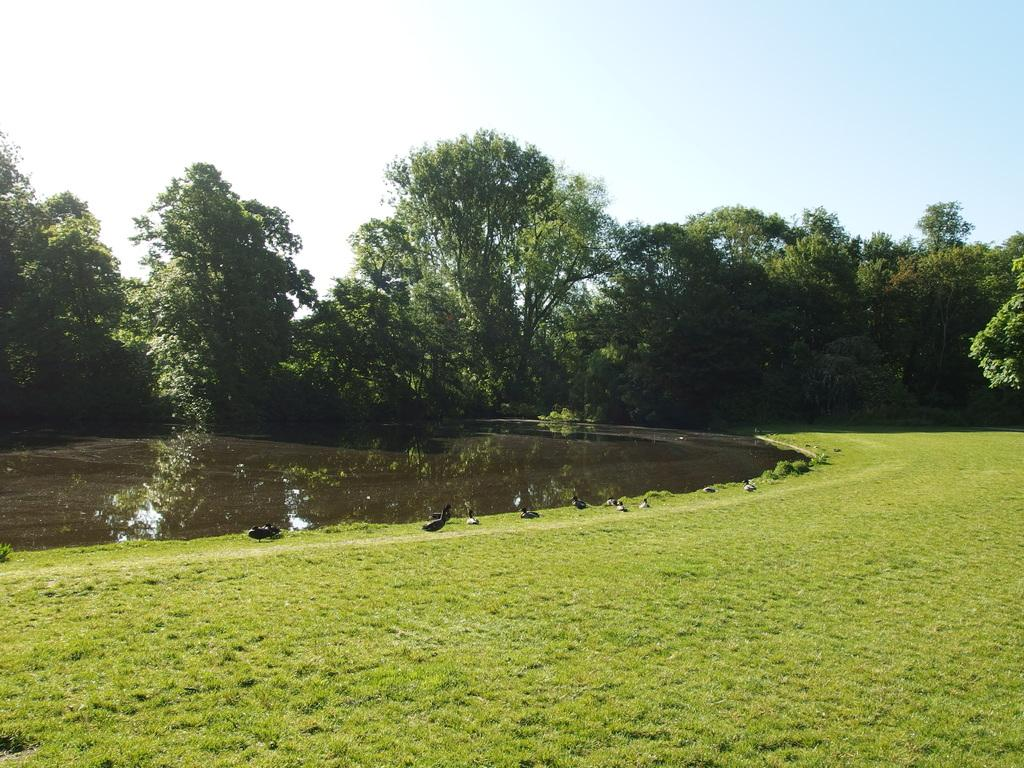What type of animals can be seen in the image? There are birds in the image. What can be seen in the background of the image? There are trees in the background of the image. What is visible at the bottom of the image? There is water and ground visible at the bottom of the image. What type of cannon is being fired in the image? There is no cannon present in the image; it features birds, trees, water, and ground. What channel can be seen on the television in the image? There is no television present in the image. 